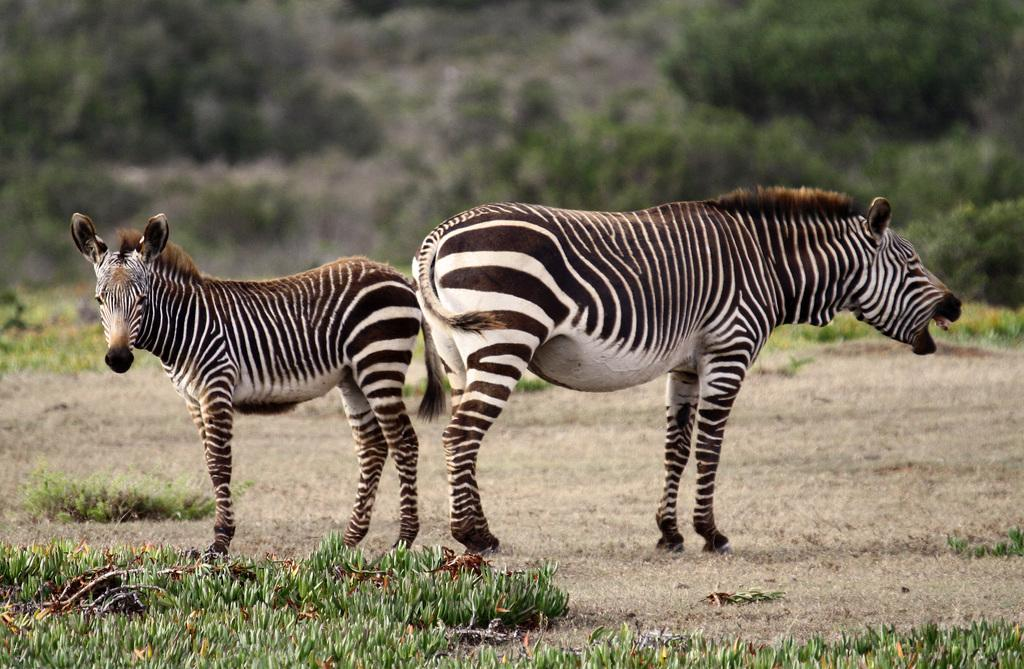What type of vegetation can be seen in the image? There is grass in the image. How many zebras are visible in the image? Two zebras are standing in the front of the image. What can be seen in the background of the image? There are plants in the background of the image. How would you describe the clarity of the background in the image? The background of the image is slightly blurry. What type of club can be seen in the image? There is no club present in the image. Can you tell me where the stamp is located in the image? There is no stamp present in the image. 